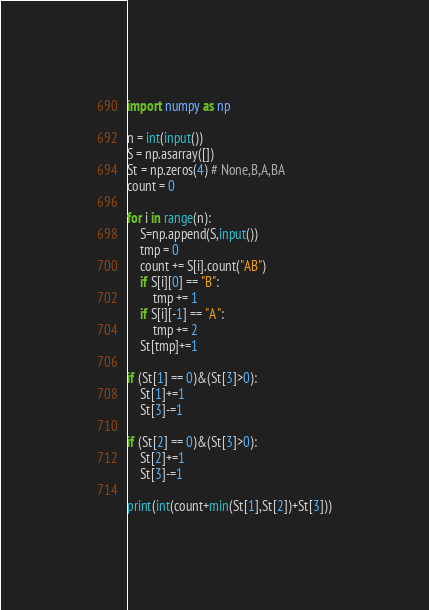Convert code to text. <code><loc_0><loc_0><loc_500><loc_500><_Python_>import numpy as np
    
n = int(input())
S = np.asarray([])
St = np.zeros(4) # None,B,A,BA
count = 0

for i in range(n):
    S=np.append(S,input())
    tmp = 0
    count += S[i].count("AB")
    if S[i][0] == "B":
        tmp += 1
    if S[i][-1] == "A":
        tmp += 2
    St[tmp]+=1

if (St[1] == 0)&(St[3]>0):
    St[1]+=1
    St[3]-=1

if (St[2] == 0)&(St[3]>0):
    St[2]+=1
    St[3]-=1

print(int(count+min(St[1],St[2])+St[3]))</code> 